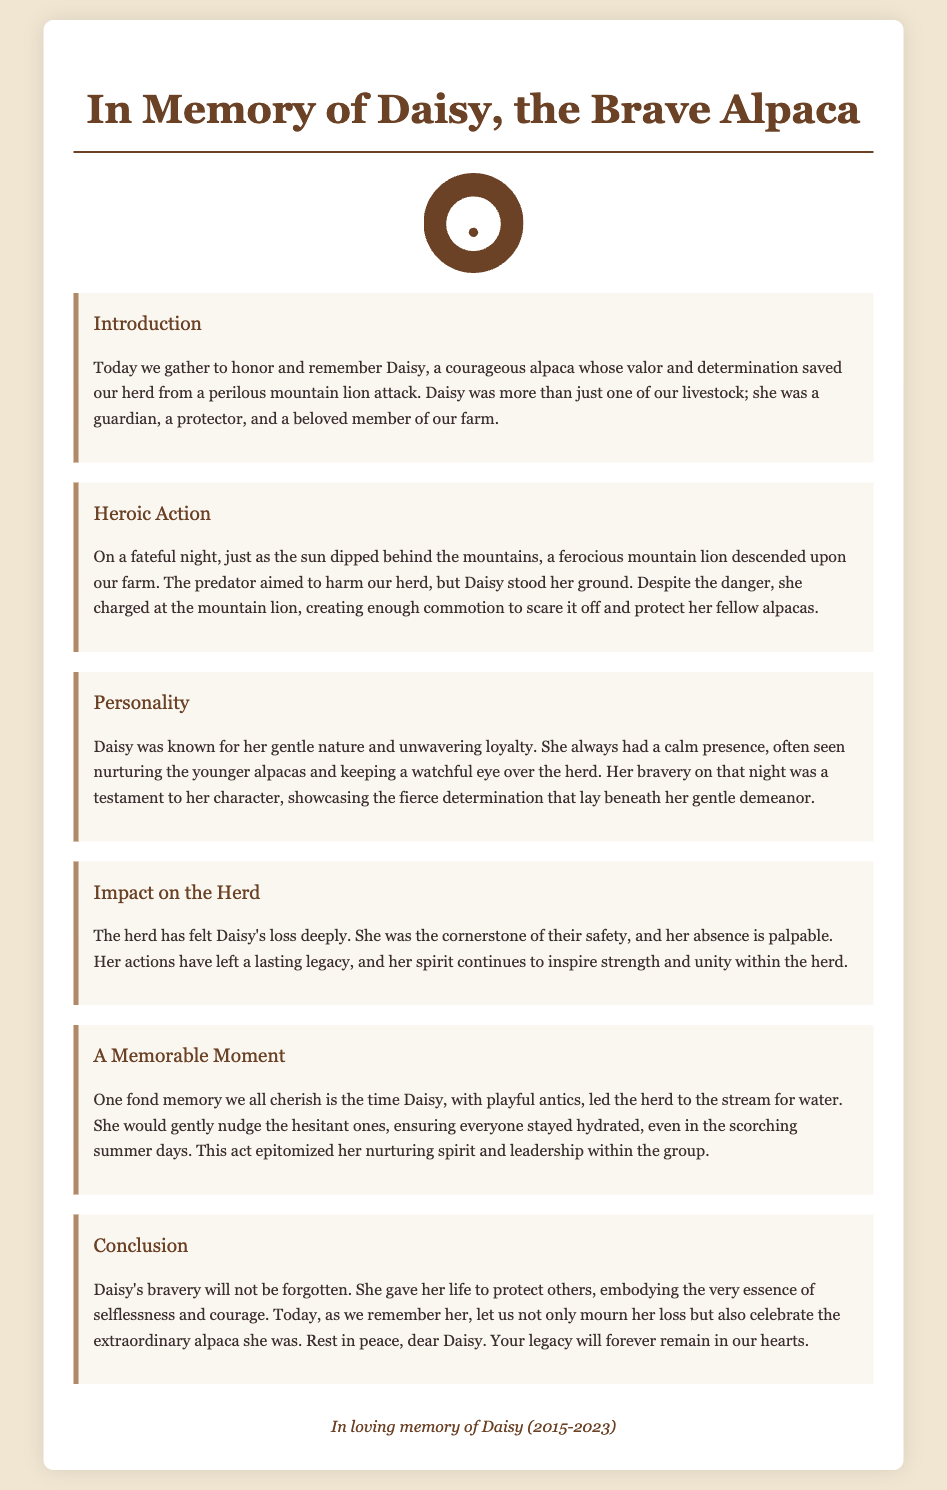What was Daisy's role on the farm? Daisy was a guardian, a protector, and a beloved member of the farm.
Answer: Guardian What did Daisy do during the mountain lion attack? Daisy charged at the mountain lion and created enough commotion to scare it off.
Answer: Scared it off When did Daisy pass away? The document mentions Daisy's lifespan from 2015 to 2023.
Answer: 2023 How did the herd feel after Daisy's loss? The herd has felt Daisy's loss deeply and her absence is palpable.
Answer: Deeply What memorable action did Daisy take to help the herd? Daisy led the herd to the stream for water and nudged the hesitant ones.
Answer: Led them to the stream What is a key personality trait of Daisy mentioned in the document? Daisy was known for her gentle nature and unwavering loyalty.
Answer: Gentle nature 